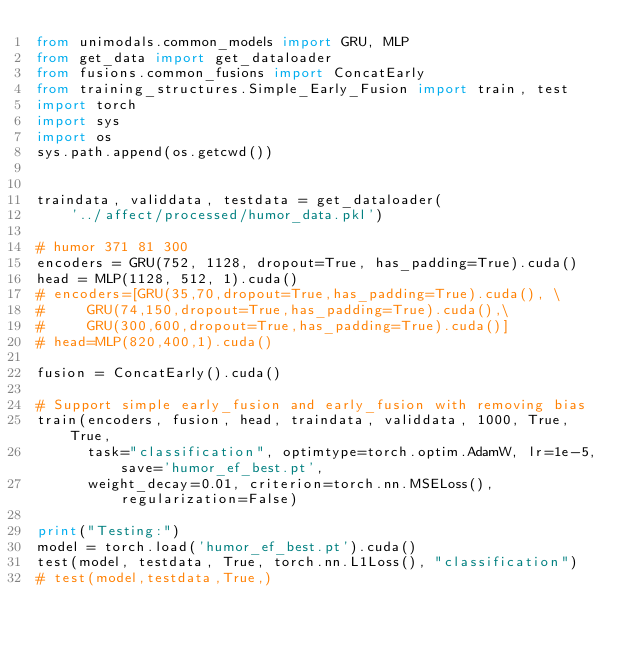Convert code to text. <code><loc_0><loc_0><loc_500><loc_500><_Python_>from unimodals.common_models import GRU, MLP
from get_data import get_dataloader
from fusions.common_fusions import ConcatEarly
from training_structures.Simple_Early_Fusion import train, test
import torch
import sys
import os
sys.path.append(os.getcwd())


traindata, validdata, testdata = get_dataloader(
    '../affect/processed/humor_data.pkl')

# humor 371 81 300
encoders = GRU(752, 1128, dropout=True, has_padding=True).cuda()
head = MLP(1128, 512, 1).cuda()
# encoders=[GRU(35,70,dropout=True,has_padding=True).cuda(), \
#     GRU(74,150,dropout=True,has_padding=True).cuda(),\
#     GRU(300,600,dropout=True,has_padding=True).cuda()]
# head=MLP(820,400,1).cuda()

fusion = ConcatEarly().cuda()

# Support simple early_fusion and early_fusion with removing bias
train(encoders, fusion, head, traindata, validdata, 1000, True, True,
      task="classification", optimtype=torch.optim.AdamW, lr=1e-5, save='humor_ef_best.pt',
      weight_decay=0.01, criterion=torch.nn.MSELoss(), regularization=False)

print("Testing:")
model = torch.load('humor_ef_best.pt').cuda()
test(model, testdata, True, torch.nn.L1Loss(), "classification")
# test(model,testdata,True,)
</code> 